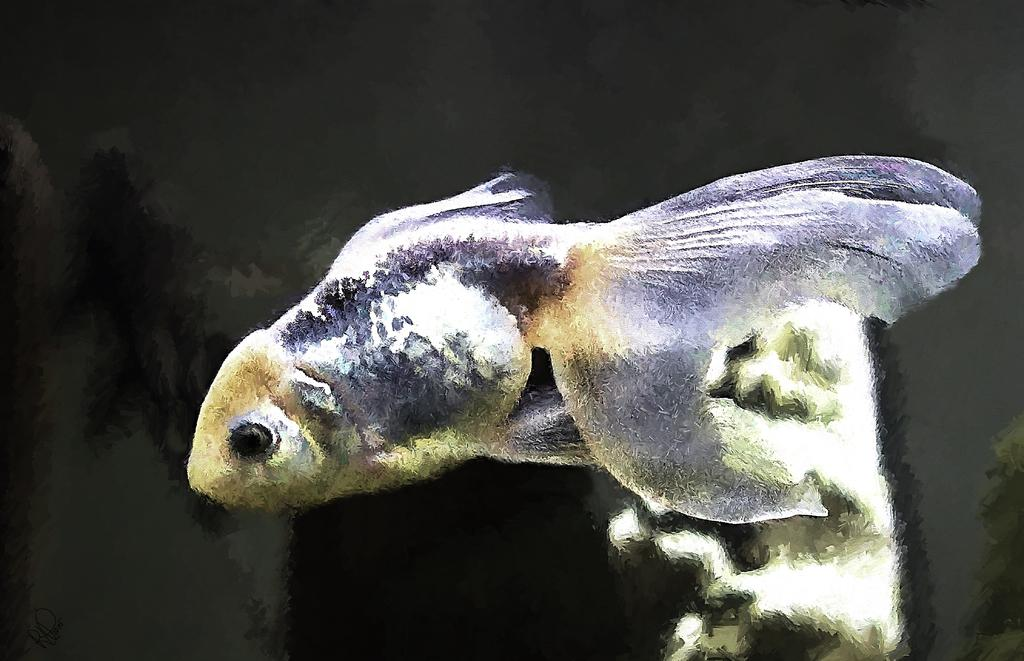What type of animal is in the image? There is a fish in the image. What color is the fish? The fish is blue in color. What is the background of the image? There is water visible in the background of the image. What type of thumb can be seen interacting with the fish in the image? There is no thumb present in the image; it only features a fish in water. 